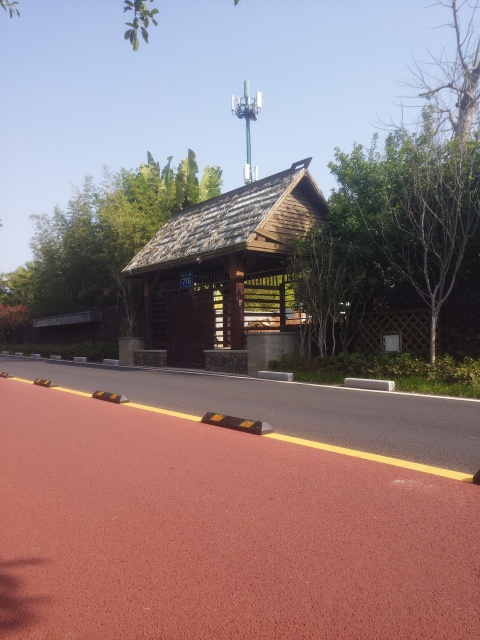Is this place suitable for taking a walk or running? Yes, the image shows a well-maintained running track with a smooth and even surface, perfect for walking or running. The surrounding greenery and pleasant aesthetic of the small house create a tranquil environment conducive to exercise or leisurely strolls. Does the area seem to be frequented by many people? Based on the image, it's difficult to gauge the usual footfall as we can't see any people present, but given the investment in a high-quality track and charming rest stop, it's likely that the area is designed to attract joggers, walkers, and those looking to relax in a scenic spot. 